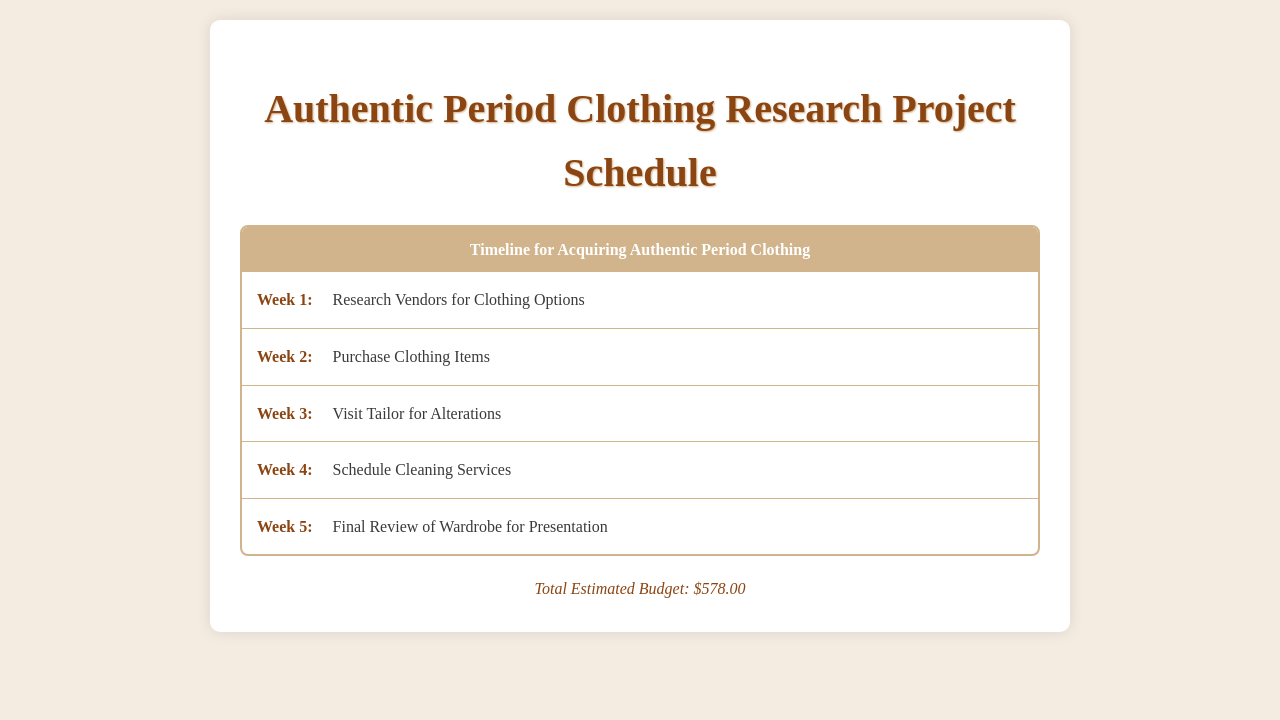What is the title of the document? The title of the document is prominently displayed at the top and reads "Authentic Period Clothing Research Project Schedule."
Answer: Authentic Period Clothing Research Project Schedule What week is designated for purchasing clothing items? The document outlines activities by week, with purchasing clothing items scheduled for Week 2.
Answer: Week 2 What is the total estimated budget? The total estimated budget is located at the bottom of the document, highlighting the total cost for the project.
Answer: $578.00 Which week involves visiting a tailor for alterations? The schedule lists activities for each week, and visiting a tailor for alterations is designated in Week 3.
Answer: Week 3 What is the activity planned for Week 4? The activities are detailed under each week, and in Week 4, the schedule indicates to "Schedule Cleaning Services."
Answer: Schedule Cleaning Services How many total weeks are indicated in the schedule? The schedule lists activities for five distinct weeks, allowing for planning and tracking progress.
Answer: Five Which week includes the final review of the wardrobe? The document specifies the final review of the wardrobe takes place in Week 5, just before presentation.
Answer: Week 5 What color is the header of the schedule? The header is mentioned in the document and is described as having a background color of #d2b48c, which is a shade of brown.
Answer: Brown What is the main purpose of the schedule? The purpose of the schedule is to organize the timeline for acquiring authentic period clothing for a research project.
Answer: Organize timeline 